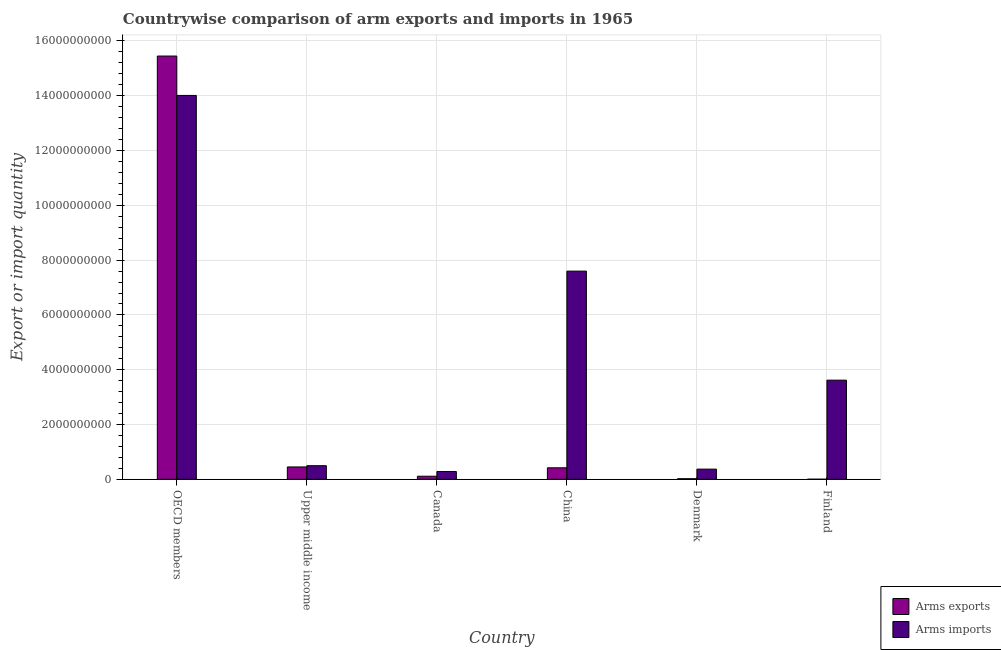How many different coloured bars are there?
Make the answer very short. 2. How many groups of bars are there?
Make the answer very short. 6. Are the number of bars per tick equal to the number of legend labels?
Your answer should be compact. Yes. How many bars are there on the 3rd tick from the left?
Make the answer very short. 2. How many bars are there on the 5th tick from the right?
Ensure brevity in your answer.  2. In how many cases, is the number of bars for a given country not equal to the number of legend labels?
Offer a terse response. 0. What is the arms imports in China?
Give a very brief answer. 7.60e+09. Across all countries, what is the maximum arms imports?
Provide a short and direct response. 1.40e+1. Across all countries, what is the minimum arms exports?
Provide a short and direct response. 1.00e+06. What is the total arms exports in the graph?
Keep it short and to the point. 1.65e+1. What is the difference between the arms exports in Denmark and that in Finland?
Offer a terse response. 1.90e+07. What is the difference between the arms exports in Canada and the arms imports in OECD members?
Your answer should be compact. -1.39e+1. What is the average arms exports per country?
Give a very brief answer. 2.74e+09. What is the difference between the arms exports and arms imports in China?
Offer a terse response. -7.18e+09. In how many countries, is the arms exports greater than 4800000000 ?
Offer a terse response. 1. What is the ratio of the arms imports in Canada to that in Denmark?
Offer a very short reply. 0.77. Is the difference between the arms imports in Canada and OECD members greater than the difference between the arms exports in Canada and OECD members?
Offer a very short reply. Yes. What is the difference between the highest and the second highest arms imports?
Offer a terse response. 6.41e+09. What is the difference between the highest and the lowest arms imports?
Your answer should be very brief. 1.37e+1. Is the sum of the arms exports in Canada and Upper middle income greater than the maximum arms imports across all countries?
Keep it short and to the point. No. What does the 1st bar from the left in Upper middle income represents?
Your response must be concise. Arms exports. What does the 1st bar from the right in OECD members represents?
Offer a terse response. Arms imports. How many bars are there?
Give a very brief answer. 12. Are all the bars in the graph horizontal?
Your response must be concise. No. Where does the legend appear in the graph?
Provide a succinct answer. Bottom right. How many legend labels are there?
Your answer should be compact. 2. How are the legend labels stacked?
Your answer should be very brief. Vertical. What is the title of the graph?
Your response must be concise. Countrywise comparison of arm exports and imports in 1965. What is the label or title of the X-axis?
Your answer should be compact. Country. What is the label or title of the Y-axis?
Ensure brevity in your answer.  Export or import quantity. What is the Export or import quantity in Arms exports in OECD members?
Offer a very short reply. 1.55e+1. What is the Export or import quantity in Arms imports in OECD members?
Your answer should be compact. 1.40e+1. What is the Export or import quantity in Arms exports in Upper middle income?
Give a very brief answer. 4.50e+08. What is the Export or import quantity in Arms imports in Upper middle income?
Ensure brevity in your answer.  4.96e+08. What is the Export or import quantity of Arms exports in Canada?
Ensure brevity in your answer.  1.11e+08. What is the Export or import quantity of Arms imports in Canada?
Your answer should be very brief. 2.84e+08. What is the Export or import quantity of Arms exports in China?
Ensure brevity in your answer.  4.19e+08. What is the Export or import quantity in Arms imports in China?
Your answer should be compact. 7.60e+09. What is the Export or import quantity of Arms imports in Denmark?
Your answer should be compact. 3.71e+08. What is the Export or import quantity in Arms exports in Finland?
Offer a terse response. 1.00e+06. What is the Export or import quantity of Arms imports in Finland?
Ensure brevity in your answer.  3.62e+09. Across all countries, what is the maximum Export or import quantity of Arms exports?
Your answer should be compact. 1.55e+1. Across all countries, what is the maximum Export or import quantity of Arms imports?
Offer a terse response. 1.40e+1. Across all countries, what is the minimum Export or import quantity of Arms exports?
Offer a terse response. 1.00e+06. Across all countries, what is the minimum Export or import quantity in Arms imports?
Give a very brief answer. 2.84e+08. What is the total Export or import quantity of Arms exports in the graph?
Ensure brevity in your answer.  1.65e+1. What is the total Export or import quantity of Arms imports in the graph?
Offer a very short reply. 2.64e+1. What is the difference between the Export or import quantity of Arms exports in OECD members and that in Upper middle income?
Your answer should be compact. 1.50e+1. What is the difference between the Export or import quantity of Arms imports in OECD members and that in Upper middle income?
Give a very brief answer. 1.35e+1. What is the difference between the Export or import quantity in Arms exports in OECD members and that in Canada?
Provide a succinct answer. 1.53e+1. What is the difference between the Export or import quantity in Arms imports in OECD members and that in Canada?
Ensure brevity in your answer.  1.37e+1. What is the difference between the Export or import quantity of Arms exports in OECD members and that in China?
Make the answer very short. 1.50e+1. What is the difference between the Export or import quantity in Arms imports in OECD members and that in China?
Make the answer very short. 6.41e+09. What is the difference between the Export or import quantity in Arms exports in OECD members and that in Denmark?
Provide a short and direct response. 1.54e+1. What is the difference between the Export or import quantity of Arms imports in OECD members and that in Denmark?
Your answer should be compact. 1.36e+1. What is the difference between the Export or import quantity in Arms exports in OECD members and that in Finland?
Ensure brevity in your answer.  1.54e+1. What is the difference between the Export or import quantity in Arms imports in OECD members and that in Finland?
Make the answer very short. 1.04e+1. What is the difference between the Export or import quantity of Arms exports in Upper middle income and that in Canada?
Keep it short and to the point. 3.39e+08. What is the difference between the Export or import quantity of Arms imports in Upper middle income and that in Canada?
Your response must be concise. 2.12e+08. What is the difference between the Export or import quantity of Arms exports in Upper middle income and that in China?
Your answer should be very brief. 3.10e+07. What is the difference between the Export or import quantity in Arms imports in Upper middle income and that in China?
Your answer should be very brief. -7.10e+09. What is the difference between the Export or import quantity in Arms exports in Upper middle income and that in Denmark?
Offer a terse response. 4.30e+08. What is the difference between the Export or import quantity in Arms imports in Upper middle income and that in Denmark?
Ensure brevity in your answer.  1.25e+08. What is the difference between the Export or import quantity in Arms exports in Upper middle income and that in Finland?
Make the answer very short. 4.49e+08. What is the difference between the Export or import quantity in Arms imports in Upper middle income and that in Finland?
Provide a succinct answer. -3.12e+09. What is the difference between the Export or import quantity of Arms exports in Canada and that in China?
Give a very brief answer. -3.08e+08. What is the difference between the Export or import quantity of Arms imports in Canada and that in China?
Provide a short and direct response. -7.32e+09. What is the difference between the Export or import quantity in Arms exports in Canada and that in Denmark?
Provide a short and direct response. 9.10e+07. What is the difference between the Export or import quantity of Arms imports in Canada and that in Denmark?
Make the answer very short. -8.70e+07. What is the difference between the Export or import quantity of Arms exports in Canada and that in Finland?
Give a very brief answer. 1.10e+08. What is the difference between the Export or import quantity of Arms imports in Canada and that in Finland?
Give a very brief answer. -3.33e+09. What is the difference between the Export or import quantity in Arms exports in China and that in Denmark?
Offer a very short reply. 3.99e+08. What is the difference between the Export or import quantity of Arms imports in China and that in Denmark?
Provide a short and direct response. 7.23e+09. What is the difference between the Export or import quantity of Arms exports in China and that in Finland?
Offer a terse response. 4.18e+08. What is the difference between the Export or import quantity in Arms imports in China and that in Finland?
Keep it short and to the point. 3.98e+09. What is the difference between the Export or import quantity in Arms exports in Denmark and that in Finland?
Keep it short and to the point. 1.90e+07. What is the difference between the Export or import quantity of Arms imports in Denmark and that in Finland?
Provide a succinct answer. -3.25e+09. What is the difference between the Export or import quantity of Arms exports in OECD members and the Export or import quantity of Arms imports in Upper middle income?
Your response must be concise. 1.50e+1. What is the difference between the Export or import quantity in Arms exports in OECD members and the Export or import quantity in Arms imports in Canada?
Make the answer very short. 1.52e+1. What is the difference between the Export or import quantity in Arms exports in OECD members and the Export or import quantity in Arms imports in China?
Provide a succinct answer. 7.85e+09. What is the difference between the Export or import quantity in Arms exports in OECD members and the Export or import quantity in Arms imports in Denmark?
Your answer should be very brief. 1.51e+1. What is the difference between the Export or import quantity in Arms exports in OECD members and the Export or import quantity in Arms imports in Finland?
Keep it short and to the point. 1.18e+1. What is the difference between the Export or import quantity of Arms exports in Upper middle income and the Export or import quantity of Arms imports in Canada?
Ensure brevity in your answer.  1.66e+08. What is the difference between the Export or import quantity in Arms exports in Upper middle income and the Export or import quantity in Arms imports in China?
Give a very brief answer. -7.15e+09. What is the difference between the Export or import quantity of Arms exports in Upper middle income and the Export or import quantity of Arms imports in Denmark?
Keep it short and to the point. 7.90e+07. What is the difference between the Export or import quantity of Arms exports in Upper middle income and the Export or import quantity of Arms imports in Finland?
Provide a succinct answer. -3.17e+09. What is the difference between the Export or import quantity in Arms exports in Canada and the Export or import quantity in Arms imports in China?
Your response must be concise. -7.49e+09. What is the difference between the Export or import quantity in Arms exports in Canada and the Export or import quantity in Arms imports in Denmark?
Offer a terse response. -2.60e+08. What is the difference between the Export or import quantity in Arms exports in Canada and the Export or import quantity in Arms imports in Finland?
Keep it short and to the point. -3.51e+09. What is the difference between the Export or import quantity in Arms exports in China and the Export or import quantity in Arms imports in Denmark?
Provide a short and direct response. 4.80e+07. What is the difference between the Export or import quantity in Arms exports in China and the Export or import quantity in Arms imports in Finland?
Your response must be concise. -3.20e+09. What is the difference between the Export or import quantity of Arms exports in Denmark and the Export or import quantity of Arms imports in Finland?
Offer a terse response. -3.60e+09. What is the average Export or import quantity of Arms exports per country?
Your response must be concise. 2.74e+09. What is the average Export or import quantity of Arms imports per country?
Make the answer very short. 4.40e+09. What is the difference between the Export or import quantity of Arms exports and Export or import quantity of Arms imports in OECD members?
Offer a very short reply. 1.44e+09. What is the difference between the Export or import quantity of Arms exports and Export or import quantity of Arms imports in Upper middle income?
Provide a short and direct response. -4.60e+07. What is the difference between the Export or import quantity of Arms exports and Export or import quantity of Arms imports in Canada?
Offer a terse response. -1.73e+08. What is the difference between the Export or import quantity in Arms exports and Export or import quantity in Arms imports in China?
Provide a succinct answer. -7.18e+09. What is the difference between the Export or import quantity of Arms exports and Export or import quantity of Arms imports in Denmark?
Provide a short and direct response. -3.51e+08. What is the difference between the Export or import quantity in Arms exports and Export or import quantity in Arms imports in Finland?
Your answer should be very brief. -3.62e+09. What is the ratio of the Export or import quantity in Arms exports in OECD members to that in Upper middle income?
Ensure brevity in your answer.  34.34. What is the ratio of the Export or import quantity in Arms imports in OECD members to that in Upper middle income?
Provide a succinct answer. 28.25. What is the ratio of the Export or import quantity in Arms exports in OECD members to that in Canada?
Offer a terse response. 139.2. What is the ratio of the Export or import quantity in Arms imports in OECD members to that in Canada?
Your response must be concise. 49.34. What is the ratio of the Export or import quantity of Arms exports in OECD members to that in China?
Your answer should be compact. 36.88. What is the ratio of the Export or import quantity in Arms imports in OECD members to that in China?
Your answer should be compact. 1.84. What is the ratio of the Export or import quantity of Arms exports in OECD members to that in Denmark?
Your response must be concise. 772.55. What is the ratio of the Export or import quantity in Arms imports in OECD members to that in Denmark?
Ensure brevity in your answer.  37.77. What is the ratio of the Export or import quantity of Arms exports in OECD members to that in Finland?
Ensure brevity in your answer.  1.55e+04. What is the ratio of the Export or import quantity in Arms imports in OECD members to that in Finland?
Offer a very short reply. 3.87. What is the ratio of the Export or import quantity in Arms exports in Upper middle income to that in Canada?
Your response must be concise. 4.05. What is the ratio of the Export or import quantity of Arms imports in Upper middle income to that in Canada?
Offer a terse response. 1.75. What is the ratio of the Export or import quantity in Arms exports in Upper middle income to that in China?
Offer a very short reply. 1.07. What is the ratio of the Export or import quantity of Arms imports in Upper middle income to that in China?
Offer a terse response. 0.07. What is the ratio of the Export or import quantity of Arms imports in Upper middle income to that in Denmark?
Offer a very short reply. 1.34. What is the ratio of the Export or import quantity of Arms exports in Upper middle income to that in Finland?
Make the answer very short. 450. What is the ratio of the Export or import quantity in Arms imports in Upper middle income to that in Finland?
Make the answer very short. 0.14. What is the ratio of the Export or import quantity of Arms exports in Canada to that in China?
Make the answer very short. 0.26. What is the ratio of the Export or import quantity of Arms imports in Canada to that in China?
Ensure brevity in your answer.  0.04. What is the ratio of the Export or import quantity of Arms exports in Canada to that in Denmark?
Keep it short and to the point. 5.55. What is the ratio of the Export or import quantity of Arms imports in Canada to that in Denmark?
Ensure brevity in your answer.  0.77. What is the ratio of the Export or import quantity of Arms exports in Canada to that in Finland?
Make the answer very short. 111. What is the ratio of the Export or import quantity in Arms imports in Canada to that in Finland?
Offer a very short reply. 0.08. What is the ratio of the Export or import quantity in Arms exports in China to that in Denmark?
Ensure brevity in your answer.  20.95. What is the ratio of the Export or import quantity in Arms imports in China to that in Denmark?
Your answer should be compact. 20.48. What is the ratio of the Export or import quantity in Arms exports in China to that in Finland?
Your answer should be very brief. 419. What is the ratio of the Export or import quantity in Arms imports in China to that in Finland?
Your response must be concise. 2.1. What is the ratio of the Export or import quantity of Arms exports in Denmark to that in Finland?
Give a very brief answer. 20. What is the ratio of the Export or import quantity in Arms imports in Denmark to that in Finland?
Provide a short and direct response. 0.1. What is the difference between the highest and the second highest Export or import quantity in Arms exports?
Ensure brevity in your answer.  1.50e+1. What is the difference between the highest and the second highest Export or import quantity of Arms imports?
Your answer should be compact. 6.41e+09. What is the difference between the highest and the lowest Export or import quantity of Arms exports?
Your answer should be compact. 1.54e+1. What is the difference between the highest and the lowest Export or import quantity in Arms imports?
Your answer should be compact. 1.37e+1. 